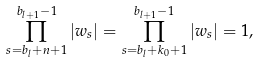Convert formula to latex. <formula><loc_0><loc_0><loc_500><loc_500>\prod _ { s = b _ { l } + n + 1 } ^ { b _ { l + 1 } - 1 } | w _ { s } | = \prod _ { s = b _ { l } + k _ { 0 } + 1 } ^ { b _ { l + 1 } - 1 } | w _ { s } | = 1 ,</formula> 